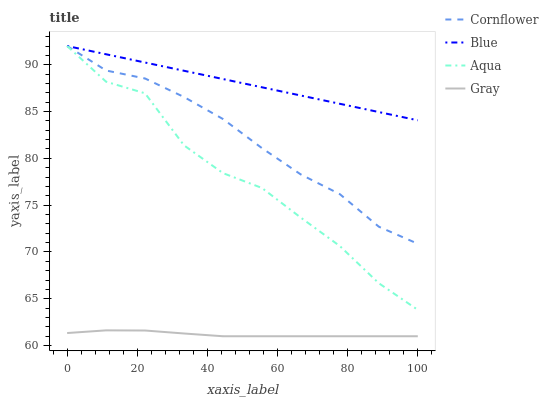Does Gray have the minimum area under the curve?
Answer yes or no. Yes. Does Blue have the maximum area under the curve?
Answer yes or no. Yes. Does Cornflower have the minimum area under the curve?
Answer yes or no. No. Does Cornflower have the maximum area under the curve?
Answer yes or no. No. Is Blue the smoothest?
Answer yes or no. Yes. Is Aqua the roughest?
Answer yes or no. Yes. Is Cornflower the smoothest?
Answer yes or no. No. Is Cornflower the roughest?
Answer yes or no. No. Does Gray have the lowest value?
Answer yes or no. Yes. Does Cornflower have the lowest value?
Answer yes or no. No. Does Aqua have the highest value?
Answer yes or no. Yes. Does Gray have the highest value?
Answer yes or no. No. Is Gray less than Aqua?
Answer yes or no. Yes. Is Blue greater than Gray?
Answer yes or no. Yes. Does Aqua intersect Blue?
Answer yes or no. Yes. Is Aqua less than Blue?
Answer yes or no. No. Is Aqua greater than Blue?
Answer yes or no. No. Does Gray intersect Aqua?
Answer yes or no. No. 